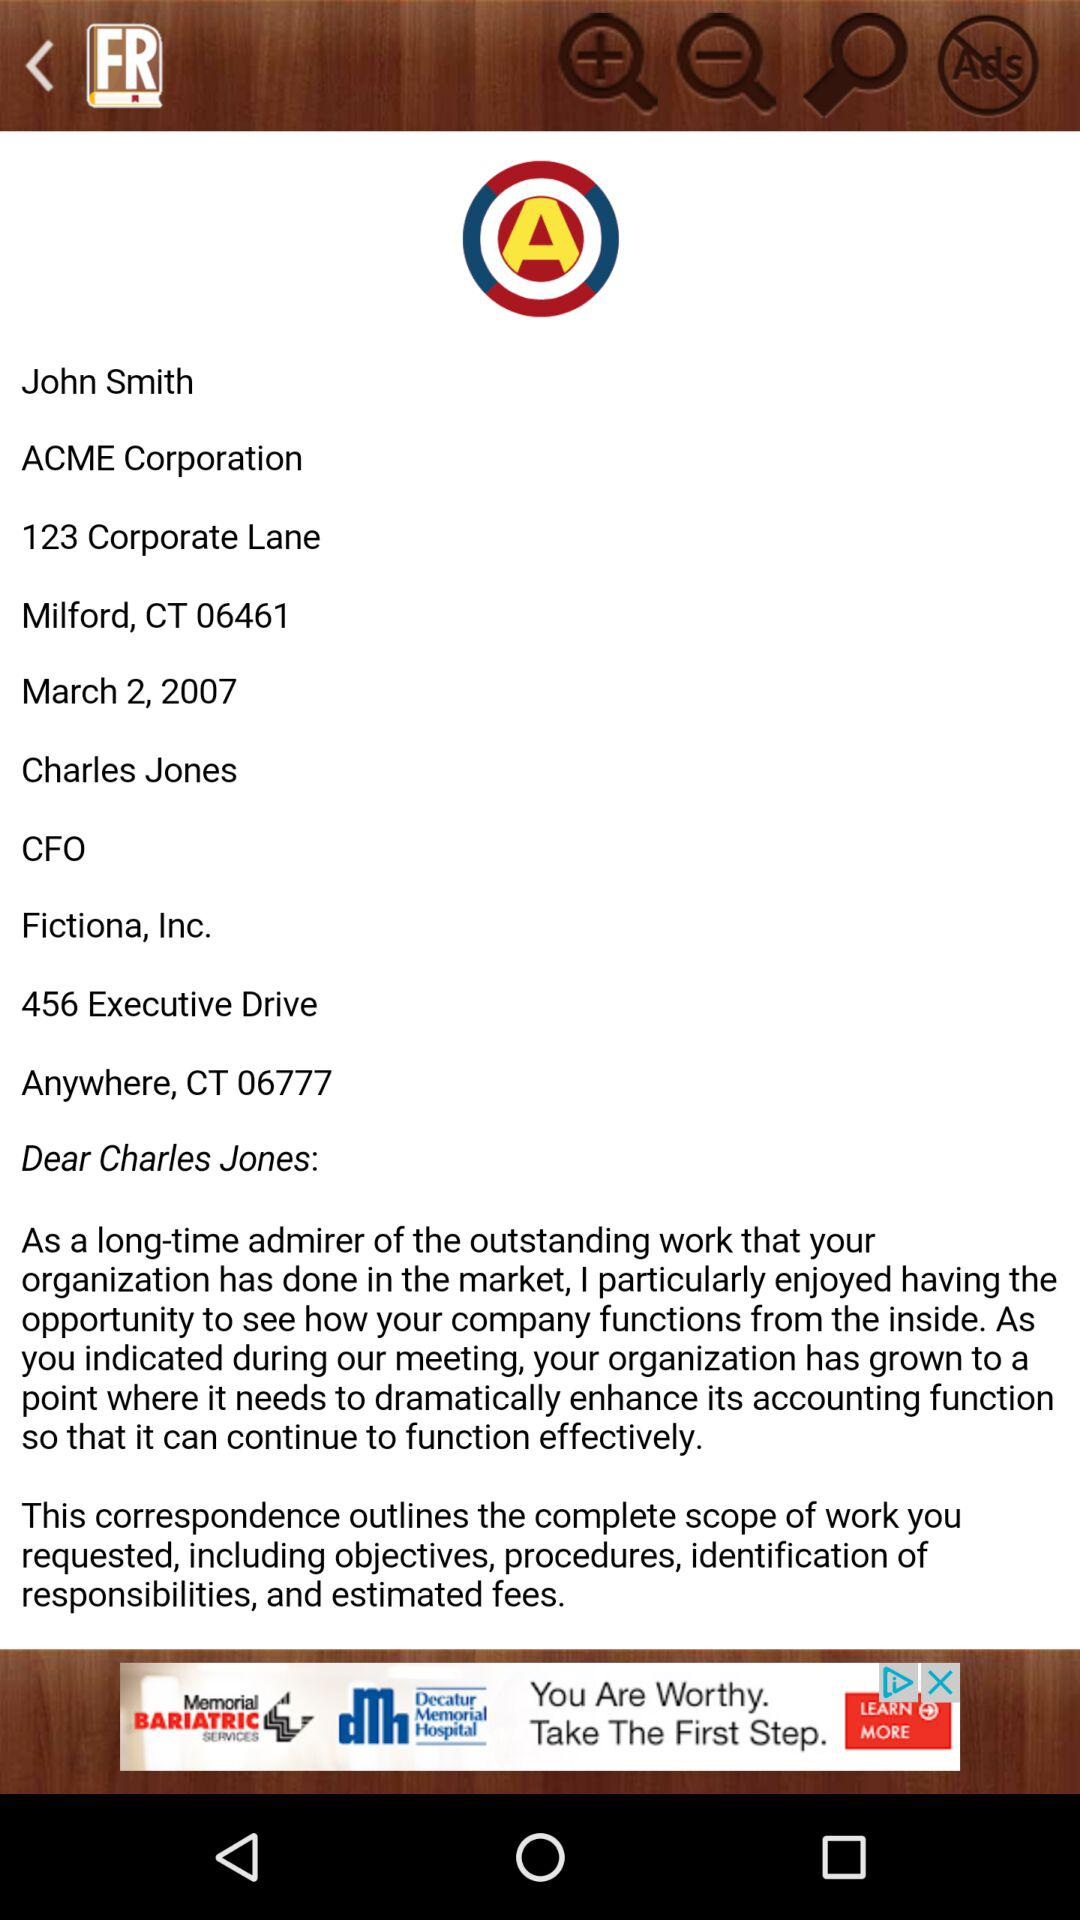What is the given date? The given date is March 2, 2007. 